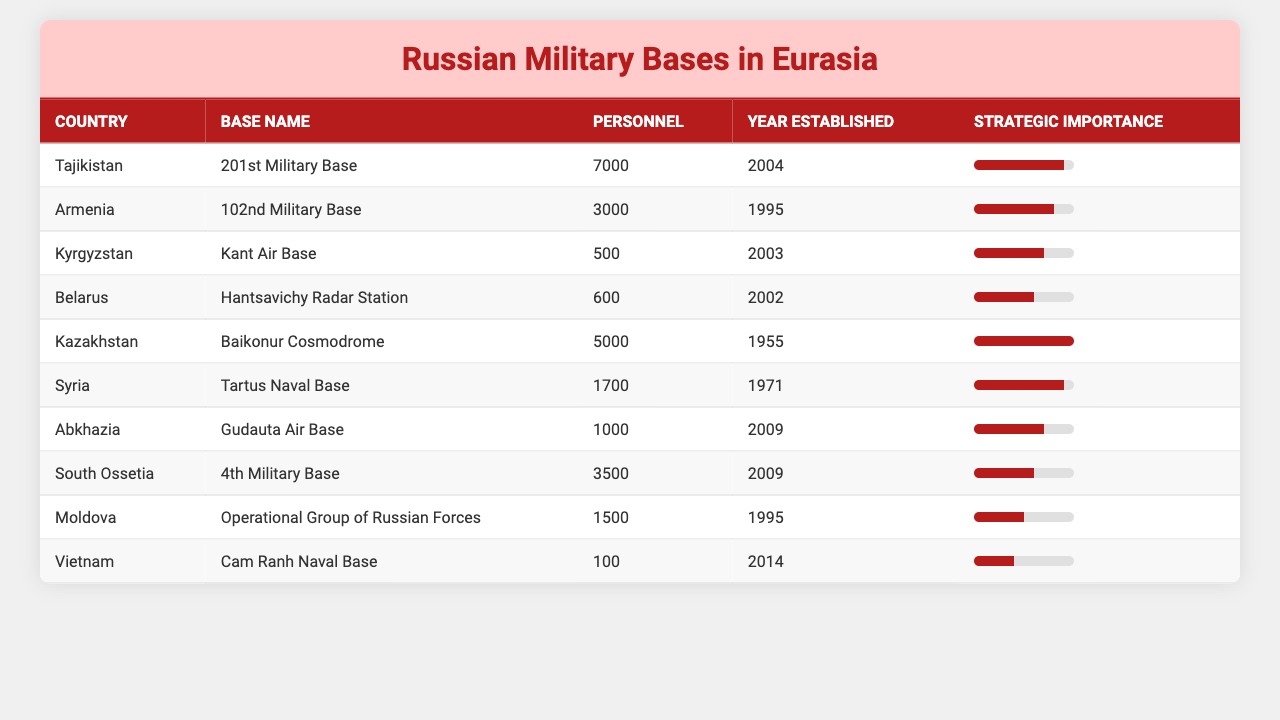What is the strategic importance rating of the 201st Military Base in Tajikistan? The table shows that the 201st Military Base in Tajikistan has a strategic importance rating of 9.
Answer: 9 How many personnel are stationed at the 102nd Military Base in Armenia? According to the table, the 102nd Military Base in Armenia has 3000 personnel.
Answer: 3000 Which military base was established in 2014? The table indicates that the Cam Ranh Naval Base in Vietnam was established in 2014.
Answer: Cam Ranh Naval Base What is the average number of personnel across all military bases listed? To find the average, sum all personnel (7000 + 3000 + 500 + 600 + 5000 + 1700 + 1000 + 3500 + 1500 + 100) = 18700. There are 10 bases, so the average is 18700/10 = 1870.
Answer: 1870 Which country hosts the military base with the highest strategic importance? The Baikonur Cosmodrome in Kazakhstan has the highest strategic importance rating of 10, which is higher than any other base.
Answer: Kazakhstan How many more personnel are at the 201st Military Base compared to the Kant Air Base? The 201st Military Base has 7000 personnel and the Kant Air Base has 500, so the difference is 7000 - 500 = 6500 personnel.
Answer: 6500 Is there a military base established in 2002? Yes, the table shows that both the Hantsavichy Radar Station in Belarus and the Kant Air Base in Kyrgyzstan were established in 2002.
Answer: Yes Which two military bases were established most recently, and what are their personnel counts? According to the table, the Gudauta Air Base in Abkhazia and the 4th Military Base in South Ossetia were both established in 2009, with personnel counts of 1000 and 3500 respectively.
Answer: Gudauta Air Base (1000), 4th Military Base (3500) What is the total number of personnel across all military bases in the listed countries? By adding all personnel from the table (7000 + 3000 + 500 + 600 + 5000 + 1700 + 1000 + 3500 + 1500 + 100), the total is 18700 personnel.
Answer: 18700 If we consider only bases with a strategic importance rating of 8 or higher, how many total personnel are there? The military bases with a strategic importance rating of 8 or higher are the 201st Military Base (7000), 102nd Military Base (3000), Tartus Naval Base (1700), and the Baikonur Cosmodrome (5000). Adding these gives 7000 + 3000 + 1700 + 5000 = 16700 personnel.
Answer: 16700 